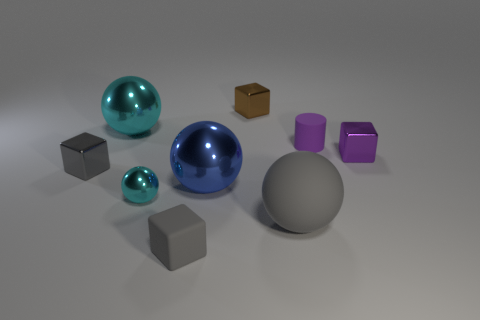How many rubber things are either tiny yellow cylinders or small cyan things?
Offer a very short reply. 0. How many big blue metallic objects are the same shape as the small cyan object?
Provide a short and direct response. 1. What is the material of the tiny thing that is the same color as the small matte cube?
Give a very brief answer. Metal. There is a matte thing that is in front of the large gray sphere; is it the same size as the cyan object that is in front of the big blue shiny ball?
Provide a short and direct response. Yes. There is a metallic object that is to the right of the rubber cylinder; what is its shape?
Offer a very short reply. Cube. There is a small cyan thing that is the same shape as the blue metallic object; what material is it?
Ensure brevity in your answer.  Metal. There is a cyan metal thing behind the purple shiny block; is its size the same as the blue metal sphere?
Your answer should be very brief. Yes. How many tiny metal objects are right of the tiny cyan ball?
Make the answer very short. 2. Is the number of gray rubber blocks that are left of the small gray rubber object less than the number of rubber blocks behind the large cyan sphere?
Keep it short and to the point. No. What number of blue shiny objects are there?
Provide a succinct answer. 1. 